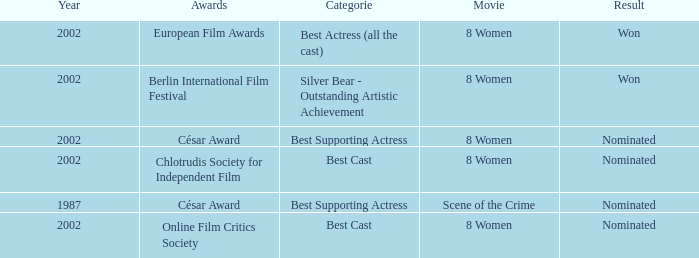What was the result at the Berlin International Film Festival in a year greater than 1987? Won. 